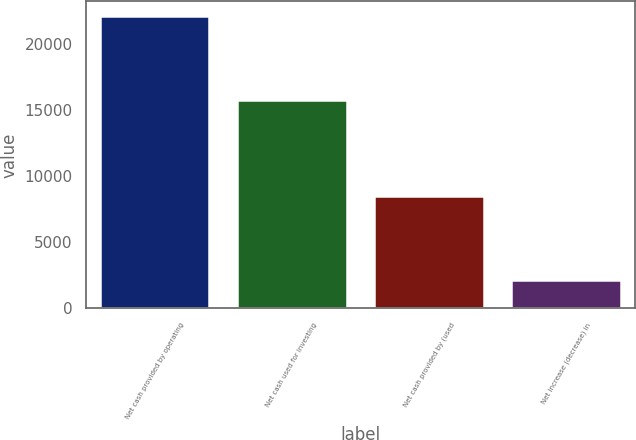Convert chart to OTSL. <chart><loc_0><loc_0><loc_500><loc_500><bar_chart><fcel>Net cash provided by operating<fcel>Net cash used for investing<fcel>Net cash provided by (used<fcel>Net increase (decrease) in<nl><fcel>22110<fcel>15762<fcel>8475<fcel>2127<nl></chart> 